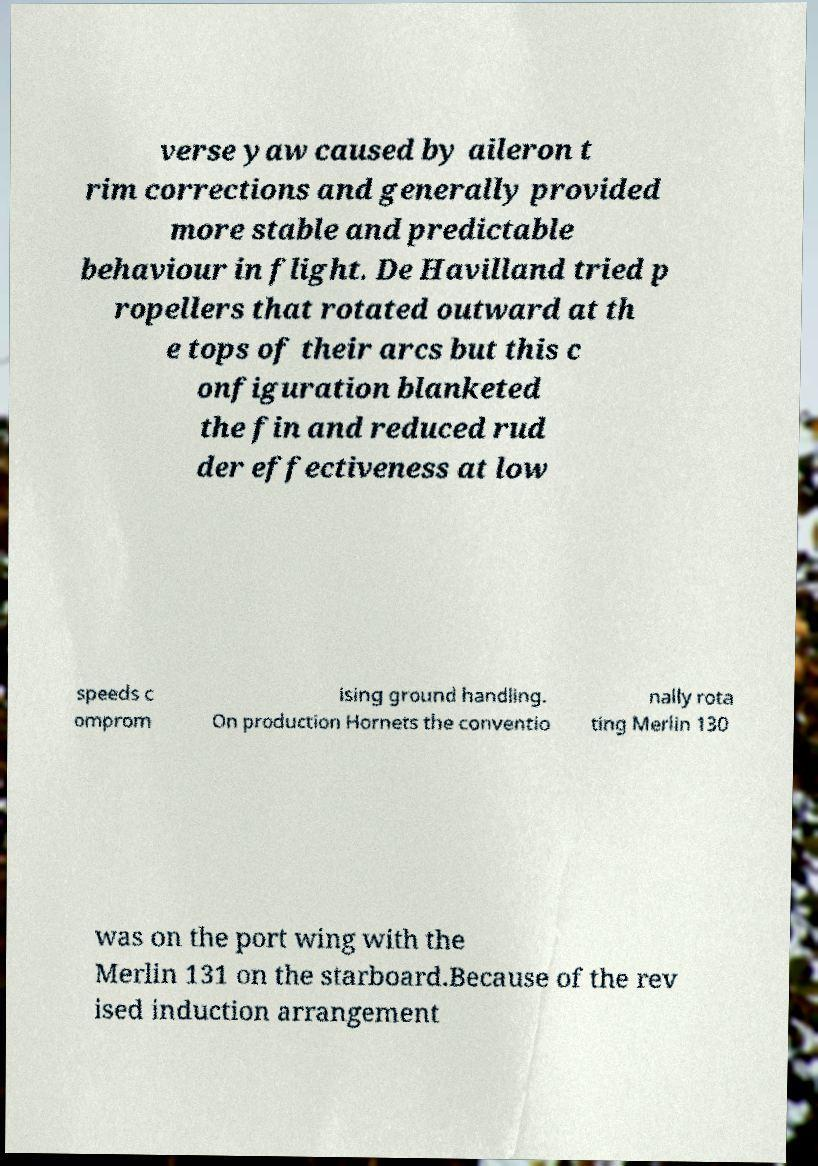For documentation purposes, I need the text within this image transcribed. Could you provide that? verse yaw caused by aileron t rim corrections and generally provided more stable and predictable behaviour in flight. De Havilland tried p ropellers that rotated outward at th e tops of their arcs but this c onfiguration blanketed the fin and reduced rud der effectiveness at low speeds c omprom ising ground handling. On production Hornets the conventio nally rota ting Merlin 130 was on the port wing with the Merlin 131 on the starboard.Because of the rev ised induction arrangement 